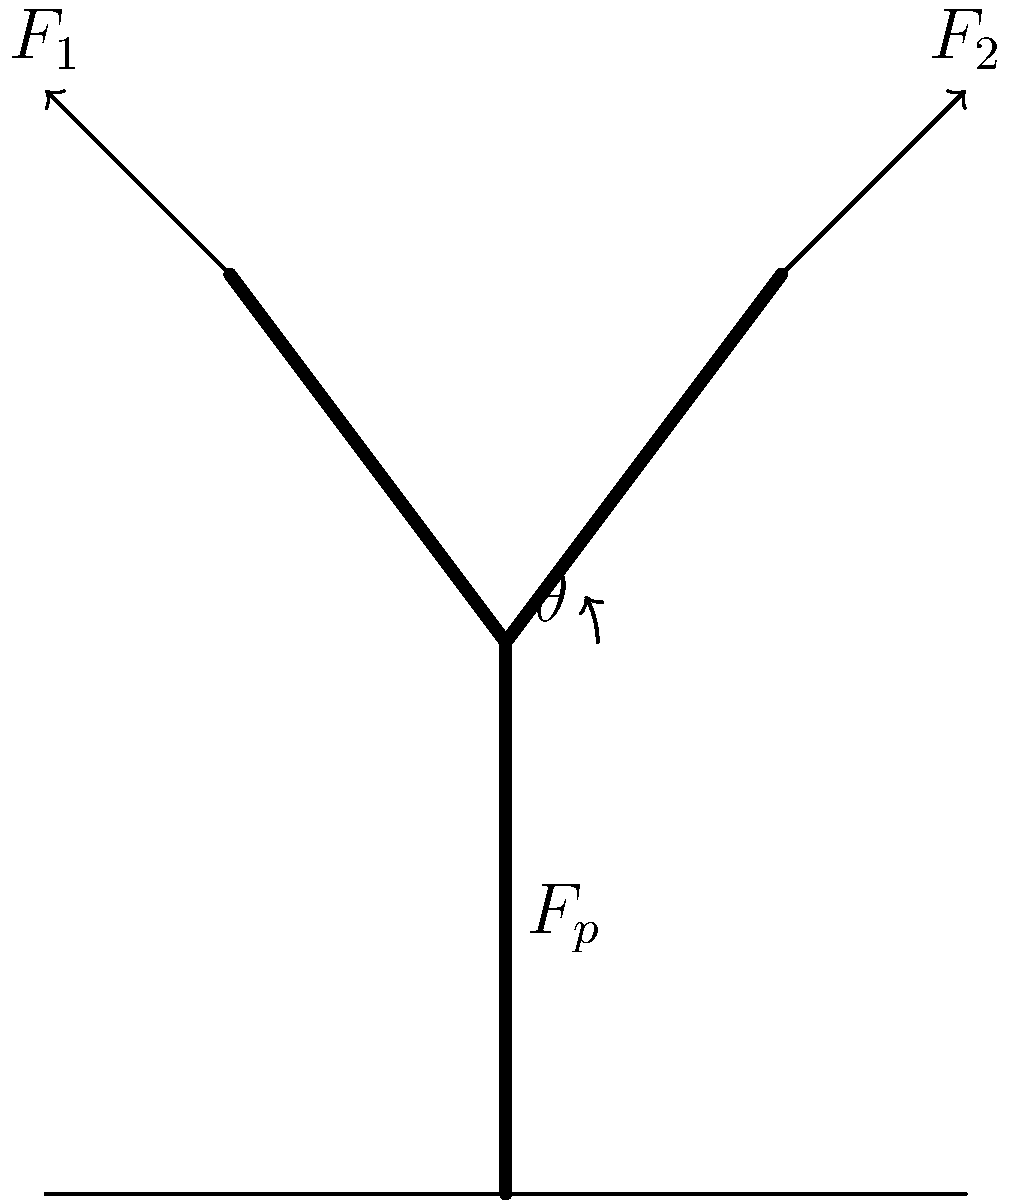As a firefighter who has used hydraulic rescue tools in emergency situations, you understand the importance of force analysis. In the diagram of a hydraulic rescue tool (jaws of life), if the piston force $F_p$ is 50 kN and the angle $\theta$ between the piston and each arm is 30°, what is the magnitude of each output force ($F_1$ and $F_2$) applied by the tool's arms? Let's approach this step-by-step:

1) In a hydraulic rescue tool, the piston force is distributed equally between the two arms. So, we can focus on one arm and its corresponding output force.

2) The force triangle for one arm consists of:
   - The piston force ($F_p/2$, as it's split between two arms)
   - The output force ($F_1$ or $F_2$)
   - The internal force along the arm

3) We're interested in the relationship between $F_p/2$ and the output force. This is governed by the angle $\theta$.

4) The output force is related to the piston force by:

   $F_{output} = \frac{F_p}{2} \cdot \frac{1}{\sin\theta}$

5) Given:
   $F_p = 50$ kN
   $\theta = 30°$

6) Plugging in the values:

   $F_{output} = \frac{50 \text{ kN}}{2} \cdot \frac{1}{\sin 30°}$

7) Simplify:
   $F_{output} = 25 \text{ kN} \cdot \frac{1}{0.5} = 50 \text{ kN}$

8) Therefore, each output force ($F_1$ and $F_2$) is 50 kN.

This analysis shows how the hydraulic rescue tool amplifies the piston force, making it an effective tool for rescue operations in situations like vehicle extrications after severe accidents or in collapsed structures during wildfires.
Answer: 50 kN 